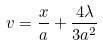Convert formula to latex. <formula><loc_0><loc_0><loc_500><loc_500>v = \frac { x } { a } + \frac { 4 \lambda } { 3 a ^ { 2 } }</formula> 